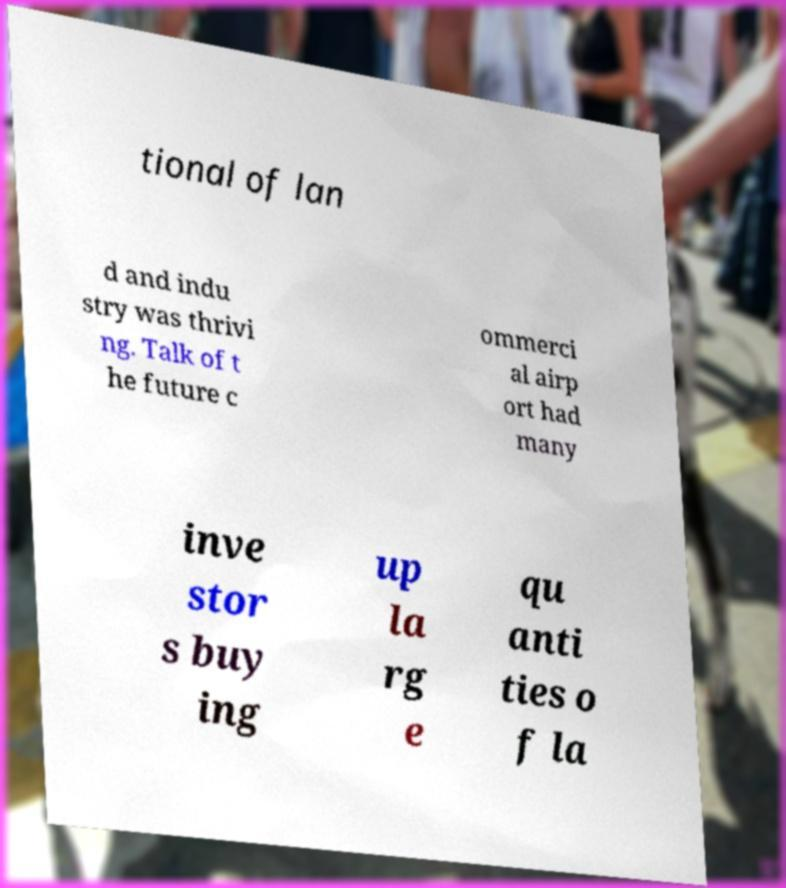Can you accurately transcribe the text from the provided image for me? tional of lan d and indu stry was thrivi ng. Talk of t he future c ommerci al airp ort had many inve stor s buy ing up la rg e qu anti ties o f la 